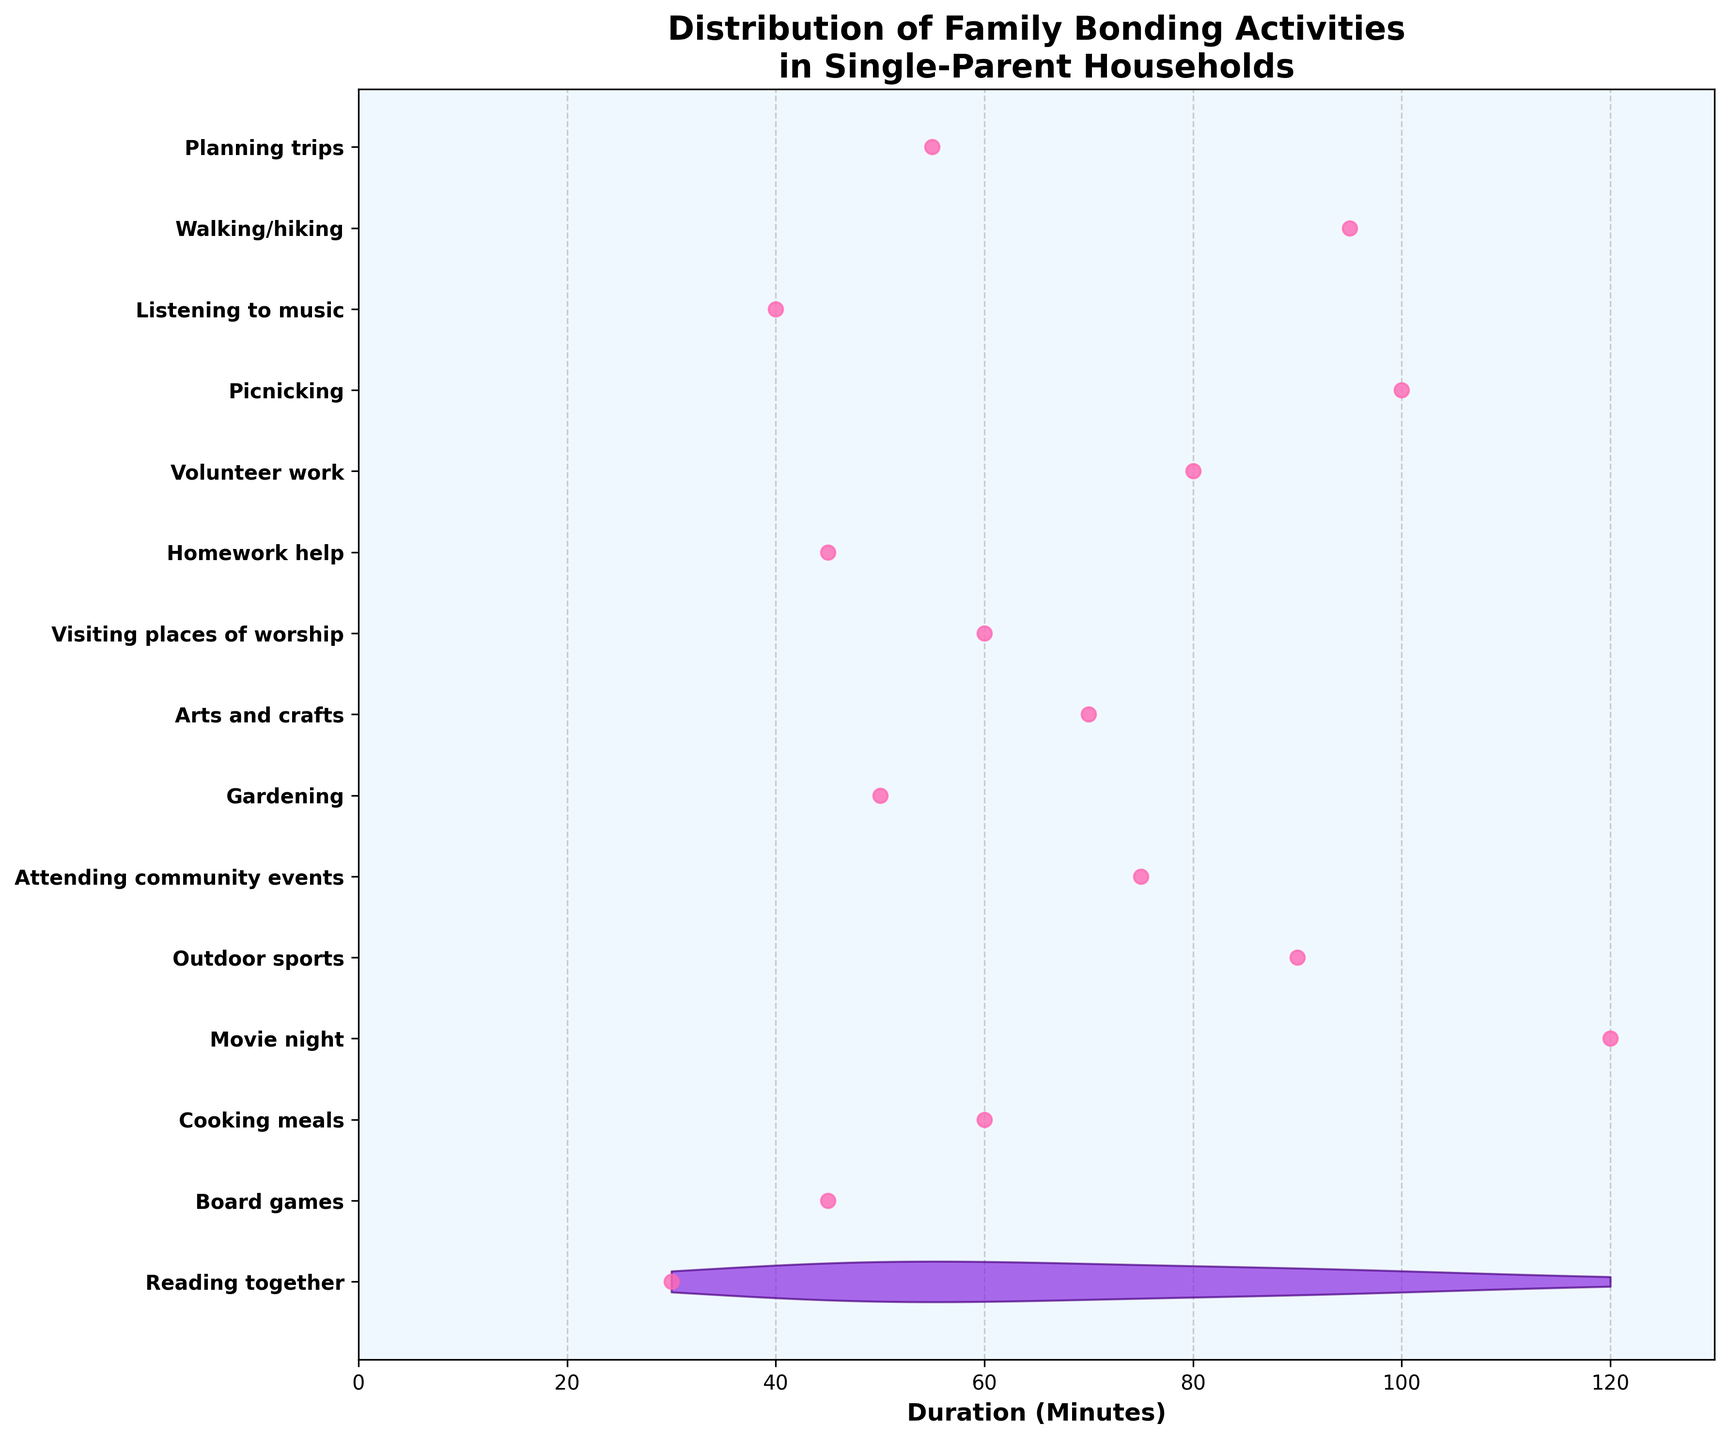What is the title of the figure? The title of the figure is typically found at the top and is often the largest text in the plot. This figure has a bold title.
Answer: Distribution of Family Bonding Activities in Single-Parent Households What is the activity with the longest duration? To determine the activity with the longest duration, look for the longest horizontal section on the chart.
Answer: Movie night How many family bonding activities are present? Count the number of unique activities listed on the y-axis, each representing a different family bonding activity.
Answer: 15 What is the shortest duration for any activity? Identify the shortest horizontal section on the chart which corresponds to the minimum duration listed on the x-axis.
Answer: 30 minutes Which activity has a duration of 50 minutes? Find the horizontal section that corresponds to 50 minutes on the x-axis and check the activity labeled on the y-axis for that plot point.
Answer: Gardening How does the duration of 'Board games' compare to 'Arts and crafts'? Locate 'Board games' and 'Arts and crafts' on the y-axis and compare their horizontal lengths on the chart. 'Board games' has a shorter duration than 'Arts and crafts'.
Answer: Board games has shorter duration What is the average duration of all activities? Add up all the durations and divide by the number of activities. Sum(30, 45, 60, 120, 90, 75, 50, 70, 60, 45, 80, 100, 40, 95, 55) = 1015. Average = 1015/15.
Answer: 67.67 minutes Which activities have durations greater than 90 minutes? Identify activities whose horizontal sections extend beyond the 90-minute mark on the x-axis.
Answer: Movie night and Picnicking What are the colors used in the violin plot and scatter points? Identify the colors by visually inspecting the plot. The violin plot has a purplish color and the scatter points are pink.
Answer: Purple for violin, pink for scatter points Is there any activity that has the same duration as attending community events? Compare the duration of "Attending community events" to other activities to see if any match. Attending community events has a duration of 75 minutes.
Answer: No Is 'Walking/hiking' duration closer to 'Movie night' or 'Reading together'? Check the duration of 'Walking/hiking' and compare it to the durations of 'Movie night' and 'Reading together'. Walking/hiking duration is 95 minutes. Movie night is 120 minutes and Reading together is 30 minutes.
Answer: Closer to Movie night 